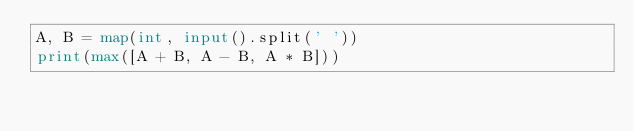<code> <loc_0><loc_0><loc_500><loc_500><_Python_>A, B = map(int, input().split(' '))
print(max([A + B, A - B, A * B]))</code> 